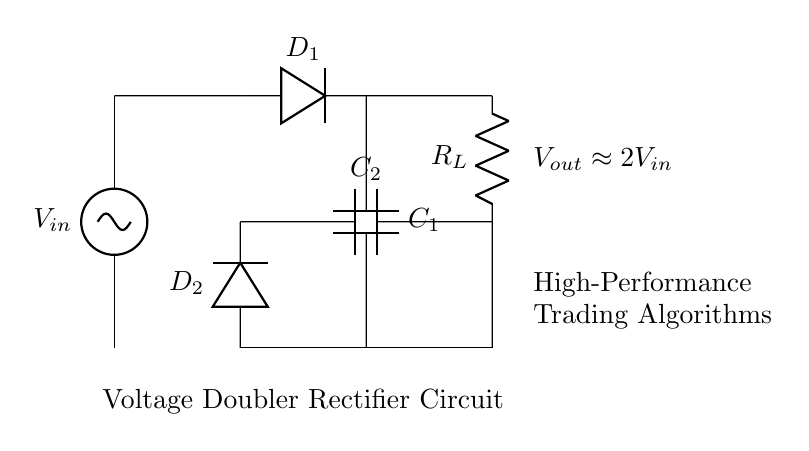What is the input voltage of this circuit? The input voltage is denoted as V_in in the diagram, which is the voltage supplied to the circuit.
Answer: V_in What does D_1 represent in this circuit? D_1 is labeled in the diagram as a diode, which allows current to pass in one direction and is crucial for rectification in this circuit.
Answer: Diode How many capacitors are present in this voltage doubler rectifier circuit? The diagram shows two capacitors, C1 and C2, which are essential for storing charge and aiding in voltage doubling.
Answer: Two How is the output voltage related to the input voltage? The circuit shows that the output voltage, V_out, is approximately twice the input voltage, as indicated in the diagram.
Answer: Approximately 2V_in What is the role of R_L in this circuit? R_L is labeled as a load resistor, which indicates that it is where the output voltage is utilized in the circuit for powering devices, such as trading algorithm computers.
Answer: Load resistor Why are there two diodes in this circuit? The two diodes, D_1 and D_2, are used in a specific arrangement to allow current to flow in both halves of the AC cycle, thereby enabling the voltage doubling feature of the circuit through rectification.
Answer: For voltage doubling 